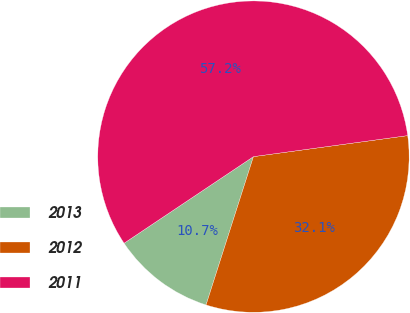<chart> <loc_0><loc_0><loc_500><loc_500><pie_chart><fcel>2013<fcel>2012<fcel>2011<nl><fcel>10.69%<fcel>32.08%<fcel>57.23%<nl></chart> 